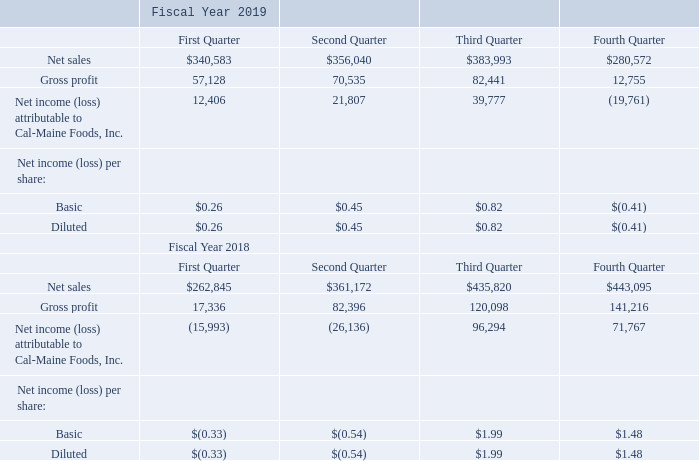16. Quarterly Financial Data: (unaudited, amount in thousands, except per share data):
During the Company's second quarter of fiscal 2019 and second quarter of fiscal 2018, we recorded $2.3 million and $80.8 million, respectively, primarily related to the legal settlement of several antitrust claims against the Company. Also during the second quarter of fiscal 2018, the Tax Cuts and Jobs Act of 2017 was enacted. This resulted in an initial revaluation of our deferred tax liabilities during the third quarter which favorably impacted our results by $35.0 million. In the fourth quarter of fiscal 2018, we completed our analysis of the Act and recorded additional tax benefit of $8.0 million.
What is the total net sales for the year ending 2019?
Answer scale should be: thousand. 340,583 + 356,040 + 383,993 + 280,572
Answer: 1361188. What is the percentage increase / (decrease) in the diluted net income (loss) per share from 2019 to 2018?
Answer scale should be: percent. 0.82 / 1.99 - 1
Answer: -58.79. What is the increase in the gross profit in 2019 from 1st quarter to 2nd quarter?
Answer scale should be: thousand. 70,535 - 57,128
Answer: 13407. What was the additional tax benefit recorded in 2018?
Answer scale should be: million. 8.0. When was the Tax Cuts and Jobs Act of 2017 enacted? 2018. What was the impact of initial revaluation of our deferred tax liabilities during the third quarter?
Answer scale should be: million. Favorably impacted our results by $35.0 million. 